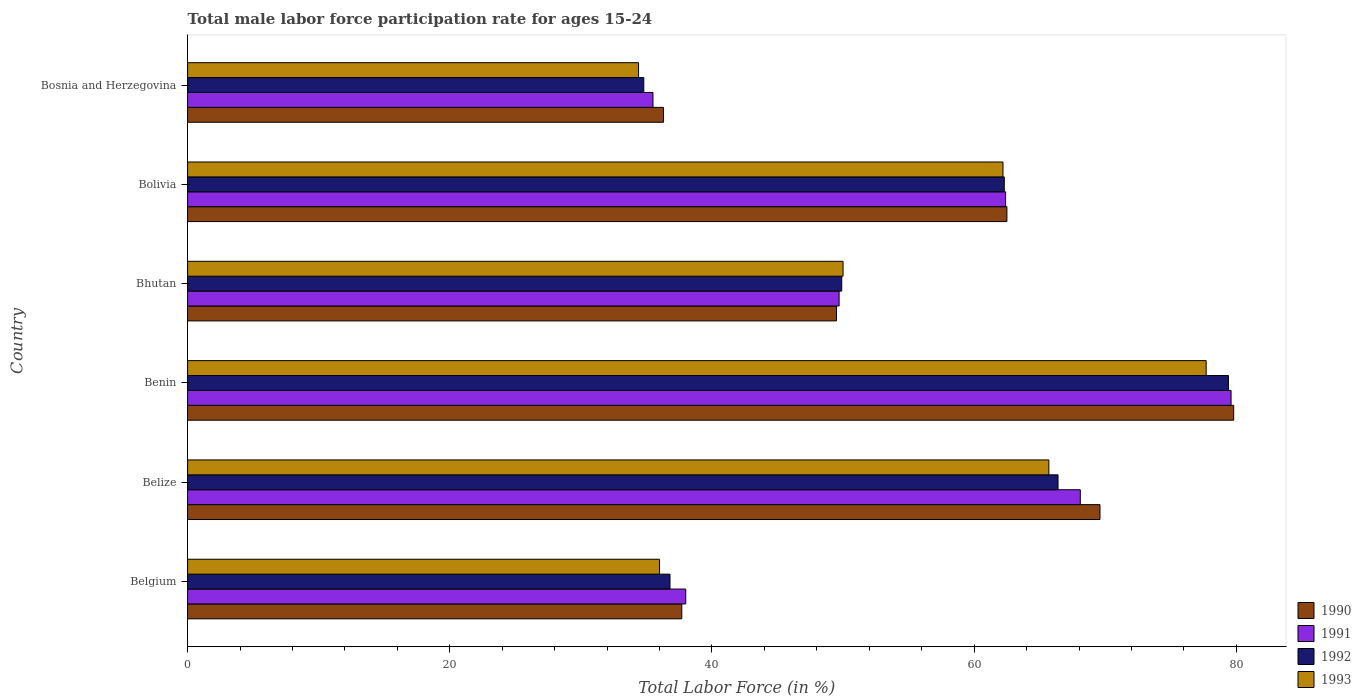How many groups of bars are there?
Offer a terse response. 6. Are the number of bars per tick equal to the number of legend labels?
Provide a succinct answer. Yes. How many bars are there on the 2nd tick from the top?
Ensure brevity in your answer.  4. What is the label of the 4th group of bars from the top?
Ensure brevity in your answer.  Benin. In how many cases, is the number of bars for a given country not equal to the number of legend labels?
Give a very brief answer. 0. What is the male labor force participation rate in 1991 in Bosnia and Herzegovina?
Your response must be concise. 35.5. Across all countries, what is the maximum male labor force participation rate in 1992?
Your response must be concise. 79.4. Across all countries, what is the minimum male labor force participation rate in 1991?
Offer a terse response. 35.5. In which country was the male labor force participation rate in 1990 maximum?
Offer a terse response. Benin. In which country was the male labor force participation rate in 1990 minimum?
Your answer should be very brief. Bosnia and Herzegovina. What is the total male labor force participation rate in 1991 in the graph?
Keep it short and to the point. 333.3. What is the difference between the male labor force participation rate in 1990 in Bhutan and that in Bolivia?
Keep it short and to the point. -13. What is the difference between the male labor force participation rate in 1992 in Bhutan and the male labor force participation rate in 1991 in Belize?
Provide a short and direct response. -18.2. What is the average male labor force participation rate in 1990 per country?
Offer a terse response. 55.9. What is the ratio of the male labor force participation rate in 1993 in Bolivia to that in Bosnia and Herzegovina?
Ensure brevity in your answer.  1.81. Is the male labor force participation rate in 1991 in Bolivia less than that in Bosnia and Herzegovina?
Your response must be concise. No. What is the difference between the highest and the lowest male labor force participation rate in 1993?
Offer a terse response. 43.3. In how many countries, is the male labor force participation rate in 1991 greater than the average male labor force participation rate in 1991 taken over all countries?
Your response must be concise. 3. Is it the case that in every country, the sum of the male labor force participation rate in 1991 and male labor force participation rate in 1993 is greater than the sum of male labor force participation rate in 1990 and male labor force participation rate in 1992?
Provide a short and direct response. No. How many bars are there?
Your response must be concise. 24. Does the graph contain any zero values?
Keep it short and to the point. No. What is the title of the graph?
Ensure brevity in your answer.  Total male labor force participation rate for ages 15-24. What is the label or title of the X-axis?
Your response must be concise. Total Labor Force (in %). What is the Total Labor Force (in %) in 1990 in Belgium?
Keep it short and to the point. 37.7. What is the Total Labor Force (in %) of 1991 in Belgium?
Your answer should be very brief. 38. What is the Total Labor Force (in %) of 1992 in Belgium?
Offer a terse response. 36.8. What is the Total Labor Force (in %) in 1990 in Belize?
Provide a short and direct response. 69.6. What is the Total Labor Force (in %) of 1991 in Belize?
Keep it short and to the point. 68.1. What is the Total Labor Force (in %) in 1992 in Belize?
Give a very brief answer. 66.4. What is the Total Labor Force (in %) of 1993 in Belize?
Your response must be concise. 65.7. What is the Total Labor Force (in %) in 1990 in Benin?
Offer a terse response. 79.8. What is the Total Labor Force (in %) of 1991 in Benin?
Give a very brief answer. 79.6. What is the Total Labor Force (in %) of 1992 in Benin?
Your answer should be very brief. 79.4. What is the Total Labor Force (in %) of 1993 in Benin?
Give a very brief answer. 77.7. What is the Total Labor Force (in %) of 1990 in Bhutan?
Make the answer very short. 49.5. What is the Total Labor Force (in %) of 1991 in Bhutan?
Your answer should be very brief. 49.7. What is the Total Labor Force (in %) in 1992 in Bhutan?
Make the answer very short. 49.9. What is the Total Labor Force (in %) in 1993 in Bhutan?
Your response must be concise. 50. What is the Total Labor Force (in %) in 1990 in Bolivia?
Offer a terse response. 62.5. What is the Total Labor Force (in %) of 1991 in Bolivia?
Offer a very short reply. 62.4. What is the Total Labor Force (in %) in 1992 in Bolivia?
Keep it short and to the point. 62.3. What is the Total Labor Force (in %) of 1993 in Bolivia?
Offer a very short reply. 62.2. What is the Total Labor Force (in %) in 1990 in Bosnia and Herzegovina?
Give a very brief answer. 36.3. What is the Total Labor Force (in %) in 1991 in Bosnia and Herzegovina?
Give a very brief answer. 35.5. What is the Total Labor Force (in %) of 1992 in Bosnia and Herzegovina?
Ensure brevity in your answer.  34.8. What is the Total Labor Force (in %) in 1993 in Bosnia and Herzegovina?
Your answer should be compact. 34.4. Across all countries, what is the maximum Total Labor Force (in %) of 1990?
Provide a succinct answer. 79.8. Across all countries, what is the maximum Total Labor Force (in %) of 1991?
Your answer should be compact. 79.6. Across all countries, what is the maximum Total Labor Force (in %) of 1992?
Keep it short and to the point. 79.4. Across all countries, what is the maximum Total Labor Force (in %) in 1993?
Make the answer very short. 77.7. Across all countries, what is the minimum Total Labor Force (in %) of 1990?
Your answer should be compact. 36.3. Across all countries, what is the minimum Total Labor Force (in %) of 1991?
Your answer should be compact. 35.5. Across all countries, what is the minimum Total Labor Force (in %) of 1992?
Provide a succinct answer. 34.8. Across all countries, what is the minimum Total Labor Force (in %) of 1993?
Give a very brief answer. 34.4. What is the total Total Labor Force (in %) of 1990 in the graph?
Offer a terse response. 335.4. What is the total Total Labor Force (in %) of 1991 in the graph?
Ensure brevity in your answer.  333.3. What is the total Total Labor Force (in %) in 1992 in the graph?
Give a very brief answer. 329.6. What is the total Total Labor Force (in %) of 1993 in the graph?
Offer a terse response. 326. What is the difference between the Total Labor Force (in %) in 1990 in Belgium and that in Belize?
Offer a very short reply. -31.9. What is the difference between the Total Labor Force (in %) in 1991 in Belgium and that in Belize?
Keep it short and to the point. -30.1. What is the difference between the Total Labor Force (in %) of 1992 in Belgium and that in Belize?
Ensure brevity in your answer.  -29.6. What is the difference between the Total Labor Force (in %) in 1993 in Belgium and that in Belize?
Offer a very short reply. -29.7. What is the difference between the Total Labor Force (in %) in 1990 in Belgium and that in Benin?
Keep it short and to the point. -42.1. What is the difference between the Total Labor Force (in %) of 1991 in Belgium and that in Benin?
Provide a short and direct response. -41.6. What is the difference between the Total Labor Force (in %) of 1992 in Belgium and that in Benin?
Offer a very short reply. -42.6. What is the difference between the Total Labor Force (in %) in 1993 in Belgium and that in Benin?
Offer a very short reply. -41.7. What is the difference between the Total Labor Force (in %) of 1991 in Belgium and that in Bhutan?
Your answer should be very brief. -11.7. What is the difference between the Total Labor Force (in %) in 1992 in Belgium and that in Bhutan?
Give a very brief answer. -13.1. What is the difference between the Total Labor Force (in %) of 1993 in Belgium and that in Bhutan?
Ensure brevity in your answer.  -14. What is the difference between the Total Labor Force (in %) in 1990 in Belgium and that in Bolivia?
Make the answer very short. -24.8. What is the difference between the Total Labor Force (in %) in 1991 in Belgium and that in Bolivia?
Offer a very short reply. -24.4. What is the difference between the Total Labor Force (in %) of 1992 in Belgium and that in Bolivia?
Your answer should be very brief. -25.5. What is the difference between the Total Labor Force (in %) in 1993 in Belgium and that in Bolivia?
Give a very brief answer. -26.2. What is the difference between the Total Labor Force (in %) in 1991 in Belgium and that in Bosnia and Herzegovina?
Provide a succinct answer. 2.5. What is the difference between the Total Labor Force (in %) in 1992 in Belgium and that in Bosnia and Herzegovina?
Offer a very short reply. 2. What is the difference between the Total Labor Force (in %) in 1991 in Belize and that in Benin?
Your answer should be very brief. -11.5. What is the difference between the Total Labor Force (in %) of 1993 in Belize and that in Benin?
Ensure brevity in your answer.  -12. What is the difference between the Total Labor Force (in %) of 1990 in Belize and that in Bhutan?
Your answer should be compact. 20.1. What is the difference between the Total Labor Force (in %) in 1990 in Belize and that in Bolivia?
Make the answer very short. 7.1. What is the difference between the Total Labor Force (in %) of 1992 in Belize and that in Bolivia?
Provide a succinct answer. 4.1. What is the difference between the Total Labor Force (in %) in 1990 in Belize and that in Bosnia and Herzegovina?
Make the answer very short. 33.3. What is the difference between the Total Labor Force (in %) in 1991 in Belize and that in Bosnia and Herzegovina?
Give a very brief answer. 32.6. What is the difference between the Total Labor Force (in %) of 1992 in Belize and that in Bosnia and Herzegovina?
Give a very brief answer. 31.6. What is the difference between the Total Labor Force (in %) in 1993 in Belize and that in Bosnia and Herzegovina?
Your response must be concise. 31.3. What is the difference between the Total Labor Force (in %) of 1990 in Benin and that in Bhutan?
Your response must be concise. 30.3. What is the difference between the Total Labor Force (in %) in 1991 in Benin and that in Bhutan?
Your response must be concise. 29.9. What is the difference between the Total Labor Force (in %) in 1992 in Benin and that in Bhutan?
Ensure brevity in your answer.  29.5. What is the difference between the Total Labor Force (in %) of 1993 in Benin and that in Bhutan?
Keep it short and to the point. 27.7. What is the difference between the Total Labor Force (in %) of 1991 in Benin and that in Bolivia?
Ensure brevity in your answer.  17.2. What is the difference between the Total Labor Force (in %) in 1993 in Benin and that in Bolivia?
Your answer should be very brief. 15.5. What is the difference between the Total Labor Force (in %) of 1990 in Benin and that in Bosnia and Herzegovina?
Offer a terse response. 43.5. What is the difference between the Total Labor Force (in %) in 1991 in Benin and that in Bosnia and Herzegovina?
Keep it short and to the point. 44.1. What is the difference between the Total Labor Force (in %) of 1992 in Benin and that in Bosnia and Herzegovina?
Keep it short and to the point. 44.6. What is the difference between the Total Labor Force (in %) in 1993 in Benin and that in Bosnia and Herzegovina?
Your answer should be very brief. 43.3. What is the difference between the Total Labor Force (in %) of 1990 in Bhutan and that in Bolivia?
Your response must be concise. -13. What is the difference between the Total Labor Force (in %) of 1992 in Bhutan and that in Bolivia?
Offer a very short reply. -12.4. What is the difference between the Total Labor Force (in %) of 1991 in Bhutan and that in Bosnia and Herzegovina?
Ensure brevity in your answer.  14.2. What is the difference between the Total Labor Force (in %) of 1992 in Bhutan and that in Bosnia and Herzegovina?
Provide a short and direct response. 15.1. What is the difference between the Total Labor Force (in %) of 1990 in Bolivia and that in Bosnia and Herzegovina?
Offer a very short reply. 26.2. What is the difference between the Total Labor Force (in %) of 1991 in Bolivia and that in Bosnia and Herzegovina?
Give a very brief answer. 26.9. What is the difference between the Total Labor Force (in %) in 1992 in Bolivia and that in Bosnia and Herzegovina?
Ensure brevity in your answer.  27.5. What is the difference between the Total Labor Force (in %) of 1993 in Bolivia and that in Bosnia and Herzegovina?
Keep it short and to the point. 27.8. What is the difference between the Total Labor Force (in %) in 1990 in Belgium and the Total Labor Force (in %) in 1991 in Belize?
Your answer should be compact. -30.4. What is the difference between the Total Labor Force (in %) of 1990 in Belgium and the Total Labor Force (in %) of 1992 in Belize?
Keep it short and to the point. -28.7. What is the difference between the Total Labor Force (in %) in 1991 in Belgium and the Total Labor Force (in %) in 1992 in Belize?
Your response must be concise. -28.4. What is the difference between the Total Labor Force (in %) in 1991 in Belgium and the Total Labor Force (in %) in 1993 in Belize?
Your response must be concise. -27.7. What is the difference between the Total Labor Force (in %) in 1992 in Belgium and the Total Labor Force (in %) in 1993 in Belize?
Ensure brevity in your answer.  -28.9. What is the difference between the Total Labor Force (in %) in 1990 in Belgium and the Total Labor Force (in %) in 1991 in Benin?
Your answer should be compact. -41.9. What is the difference between the Total Labor Force (in %) in 1990 in Belgium and the Total Labor Force (in %) in 1992 in Benin?
Offer a very short reply. -41.7. What is the difference between the Total Labor Force (in %) of 1990 in Belgium and the Total Labor Force (in %) of 1993 in Benin?
Provide a short and direct response. -40. What is the difference between the Total Labor Force (in %) of 1991 in Belgium and the Total Labor Force (in %) of 1992 in Benin?
Offer a terse response. -41.4. What is the difference between the Total Labor Force (in %) in 1991 in Belgium and the Total Labor Force (in %) in 1993 in Benin?
Keep it short and to the point. -39.7. What is the difference between the Total Labor Force (in %) of 1992 in Belgium and the Total Labor Force (in %) of 1993 in Benin?
Provide a short and direct response. -40.9. What is the difference between the Total Labor Force (in %) in 1990 in Belgium and the Total Labor Force (in %) in 1993 in Bhutan?
Your answer should be compact. -12.3. What is the difference between the Total Labor Force (in %) of 1991 in Belgium and the Total Labor Force (in %) of 1992 in Bhutan?
Your answer should be very brief. -11.9. What is the difference between the Total Labor Force (in %) in 1991 in Belgium and the Total Labor Force (in %) in 1993 in Bhutan?
Your answer should be very brief. -12. What is the difference between the Total Labor Force (in %) in 1990 in Belgium and the Total Labor Force (in %) in 1991 in Bolivia?
Offer a very short reply. -24.7. What is the difference between the Total Labor Force (in %) of 1990 in Belgium and the Total Labor Force (in %) of 1992 in Bolivia?
Give a very brief answer. -24.6. What is the difference between the Total Labor Force (in %) of 1990 in Belgium and the Total Labor Force (in %) of 1993 in Bolivia?
Keep it short and to the point. -24.5. What is the difference between the Total Labor Force (in %) in 1991 in Belgium and the Total Labor Force (in %) in 1992 in Bolivia?
Your answer should be very brief. -24.3. What is the difference between the Total Labor Force (in %) in 1991 in Belgium and the Total Labor Force (in %) in 1993 in Bolivia?
Offer a terse response. -24.2. What is the difference between the Total Labor Force (in %) of 1992 in Belgium and the Total Labor Force (in %) of 1993 in Bolivia?
Make the answer very short. -25.4. What is the difference between the Total Labor Force (in %) in 1990 in Belgium and the Total Labor Force (in %) in 1991 in Bosnia and Herzegovina?
Your answer should be very brief. 2.2. What is the difference between the Total Labor Force (in %) of 1990 in Belgium and the Total Labor Force (in %) of 1992 in Bosnia and Herzegovina?
Make the answer very short. 2.9. What is the difference between the Total Labor Force (in %) in 1990 in Belgium and the Total Labor Force (in %) in 1993 in Bosnia and Herzegovina?
Give a very brief answer. 3.3. What is the difference between the Total Labor Force (in %) of 1991 in Belgium and the Total Labor Force (in %) of 1992 in Bosnia and Herzegovina?
Your answer should be very brief. 3.2. What is the difference between the Total Labor Force (in %) of 1990 in Belize and the Total Labor Force (in %) of 1991 in Benin?
Keep it short and to the point. -10. What is the difference between the Total Labor Force (in %) in 1990 in Belize and the Total Labor Force (in %) in 1993 in Benin?
Offer a very short reply. -8.1. What is the difference between the Total Labor Force (in %) in 1990 in Belize and the Total Labor Force (in %) in 1993 in Bhutan?
Offer a terse response. 19.6. What is the difference between the Total Labor Force (in %) of 1991 in Belize and the Total Labor Force (in %) of 1992 in Bhutan?
Provide a short and direct response. 18.2. What is the difference between the Total Labor Force (in %) in 1991 in Belize and the Total Labor Force (in %) in 1993 in Bhutan?
Your answer should be compact. 18.1. What is the difference between the Total Labor Force (in %) of 1990 in Belize and the Total Labor Force (in %) of 1991 in Bolivia?
Your answer should be very brief. 7.2. What is the difference between the Total Labor Force (in %) of 1990 in Belize and the Total Labor Force (in %) of 1992 in Bolivia?
Offer a very short reply. 7.3. What is the difference between the Total Labor Force (in %) of 1991 in Belize and the Total Labor Force (in %) of 1993 in Bolivia?
Make the answer very short. 5.9. What is the difference between the Total Labor Force (in %) in 1992 in Belize and the Total Labor Force (in %) in 1993 in Bolivia?
Your answer should be very brief. 4.2. What is the difference between the Total Labor Force (in %) of 1990 in Belize and the Total Labor Force (in %) of 1991 in Bosnia and Herzegovina?
Your answer should be compact. 34.1. What is the difference between the Total Labor Force (in %) in 1990 in Belize and the Total Labor Force (in %) in 1992 in Bosnia and Herzegovina?
Your answer should be very brief. 34.8. What is the difference between the Total Labor Force (in %) in 1990 in Belize and the Total Labor Force (in %) in 1993 in Bosnia and Herzegovina?
Give a very brief answer. 35.2. What is the difference between the Total Labor Force (in %) in 1991 in Belize and the Total Labor Force (in %) in 1992 in Bosnia and Herzegovina?
Offer a very short reply. 33.3. What is the difference between the Total Labor Force (in %) of 1991 in Belize and the Total Labor Force (in %) of 1993 in Bosnia and Herzegovina?
Your answer should be very brief. 33.7. What is the difference between the Total Labor Force (in %) in 1992 in Belize and the Total Labor Force (in %) in 1993 in Bosnia and Herzegovina?
Make the answer very short. 32. What is the difference between the Total Labor Force (in %) in 1990 in Benin and the Total Labor Force (in %) in 1991 in Bhutan?
Your answer should be very brief. 30.1. What is the difference between the Total Labor Force (in %) in 1990 in Benin and the Total Labor Force (in %) in 1992 in Bhutan?
Offer a terse response. 29.9. What is the difference between the Total Labor Force (in %) of 1990 in Benin and the Total Labor Force (in %) of 1993 in Bhutan?
Your answer should be compact. 29.8. What is the difference between the Total Labor Force (in %) in 1991 in Benin and the Total Labor Force (in %) in 1992 in Bhutan?
Give a very brief answer. 29.7. What is the difference between the Total Labor Force (in %) in 1991 in Benin and the Total Labor Force (in %) in 1993 in Bhutan?
Offer a very short reply. 29.6. What is the difference between the Total Labor Force (in %) of 1992 in Benin and the Total Labor Force (in %) of 1993 in Bhutan?
Give a very brief answer. 29.4. What is the difference between the Total Labor Force (in %) of 1990 in Benin and the Total Labor Force (in %) of 1992 in Bolivia?
Your answer should be compact. 17.5. What is the difference between the Total Labor Force (in %) in 1991 in Benin and the Total Labor Force (in %) in 1992 in Bolivia?
Your response must be concise. 17.3. What is the difference between the Total Labor Force (in %) of 1991 in Benin and the Total Labor Force (in %) of 1993 in Bolivia?
Your answer should be very brief. 17.4. What is the difference between the Total Labor Force (in %) of 1992 in Benin and the Total Labor Force (in %) of 1993 in Bolivia?
Offer a very short reply. 17.2. What is the difference between the Total Labor Force (in %) of 1990 in Benin and the Total Labor Force (in %) of 1991 in Bosnia and Herzegovina?
Your response must be concise. 44.3. What is the difference between the Total Labor Force (in %) in 1990 in Benin and the Total Labor Force (in %) in 1992 in Bosnia and Herzegovina?
Provide a short and direct response. 45. What is the difference between the Total Labor Force (in %) of 1990 in Benin and the Total Labor Force (in %) of 1993 in Bosnia and Herzegovina?
Your answer should be compact. 45.4. What is the difference between the Total Labor Force (in %) of 1991 in Benin and the Total Labor Force (in %) of 1992 in Bosnia and Herzegovina?
Provide a succinct answer. 44.8. What is the difference between the Total Labor Force (in %) of 1991 in Benin and the Total Labor Force (in %) of 1993 in Bosnia and Herzegovina?
Offer a terse response. 45.2. What is the difference between the Total Labor Force (in %) in 1990 in Bhutan and the Total Labor Force (in %) in 1991 in Bolivia?
Make the answer very short. -12.9. What is the difference between the Total Labor Force (in %) of 1991 in Bhutan and the Total Labor Force (in %) of 1993 in Bolivia?
Keep it short and to the point. -12.5. What is the difference between the Total Labor Force (in %) in 1992 in Bhutan and the Total Labor Force (in %) in 1993 in Bolivia?
Make the answer very short. -12.3. What is the difference between the Total Labor Force (in %) of 1990 in Bhutan and the Total Labor Force (in %) of 1993 in Bosnia and Herzegovina?
Provide a short and direct response. 15.1. What is the difference between the Total Labor Force (in %) in 1992 in Bhutan and the Total Labor Force (in %) in 1993 in Bosnia and Herzegovina?
Your response must be concise. 15.5. What is the difference between the Total Labor Force (in %) in 1990 in Bolivia and the Total Labor Force (in %) in 1991 in Bosnia and Herzegovina?
Give a very brief answer. 27. What is the difference between the Total Labor Force (in %) in 1990 in Bolivia and the Total Labor Force (in %) in 1992 in Bosnia and Herzegovina?
Give a very brief answer. 27.7. What is the difference between the Total Labor Force (in %) in 1990 in Bolivia and the Total Labor Force (in %) in 1993 in Bosnia and Herzegovina?
Keep it short and to the point. 28.1. What is the difference between the Total Labor Force (in %) of 1991 in Bolivia and the Total Labor Force (in %) of 1992 in Bosnia and Herzegovina?
Keep it short and to the point. 27.6. What is the difference between the Total Labor Force (in %) in 1992 in Bolivia and the Total Labor Force (in %) in 1993 in Bosnia and Herzegovina?
Your response must be concise. 27.9. What is the average Total Labor Force (in %) of 1990 per country?
Offer a terse response. 55.9. What is the average Total Labor Force (in %) of 1991 per country?
Your answer should be very brief. 55.55. What is the average Total Labor Force (in %) in 1992 per country?
Offer a terse response. 54.93. What is the average Total Labor Force (in %) of 1993 per country?
Offer a terse response. 54.33. What is the difference between the Total Labor Force (in %) of 1990 and Total Labor Force (in %) of 1992 in Belgium?
Provide a short and direct response. 0.9. What is the difference between the Total Labor Force (in %) of 1990 and Total Labor Force (in %) of 1993 in Belgium?
Give a very brief answer. 1.7. What is the difference between the Total Labor Force (in %) of 1990 and Total Labor Force (in %) of 1991 in Belize?
Ensure brevity in your answer.  1.5. What is the difference between the Total Labor Force (in %) of 1990 and Total Labor Force (in %) of 1992 in Belize?
Your response must be concise. 3.2. What is the difference between the Total Labor Force (in %) of 1991 and Total Labor Force (in %) of 1992 in Belize?
Offer a terse response. 1.7. What is the difference between the Total Labor Force (in %) of 1992 and Total Labor Force (in %) of 1993 in Belize?
Your answer should be compact. 0.7. What is the difference between the Total Labor Force (in %) in 1991 and Total Labor Force (in %) in 1992 in Benin?
Offer a terse response. 0.2. What is the difference between the Total Labor Force (in %) in 1991 and Total Labor Force (in %) in 1993 in Benin?
Provide a short and direct response. 1.9. What is the difference between the Total Labor Force (in %) of 1990 and Total Labor Force (in %) of 1991 in Bhutan?
Provide a succinct answer. -0.2. What is the difference between the Total Labor Force (in %) in 1991 and Total Labor Force (in %) in 1992 in Bhutan?
Give a very brief answer. -0.2. What is the difference between the Total Labor Force (in %) in 1991 and Total Labor Force (in %) in 1993 in Bhutan?
Your answer should be compact. -0.3. What is the difference between the Total Labor Force (in %) in 1992 and Total Labor Force (in %) in 1993 in Bhutan?
Provide a succinct answer. -0.1. What is the difference between the Total Labor Force (in %) of 1990 and Total Labor Force (in %) of 1991 in Bolivia?
Your answer should be very brief. 0.1. What is the difference between the Total Labor Force (in %) in 1990 and Total Labor Force (in %) in 1993 in Bolivia?
Your response must be concise. 0.3. What is the difference between the Total Labor Force (in %) in 1991 and Total Labor Force (in %) in 1992 in Bolivia?
Give a very brief answer. 0.1. What is the difference between the Total Labor Force (in %) in 1990 and Total Labor Force (in %) in 1992 in Bosnia and Herzegovina?
Your answer should be compact. 1.5. What is the difference between the Total Labor Force (in %) of 1990 and Total Labor Force (in %) of 1993 in Bosnia and Herzegovina?
Your answer should be very brief. 1.9. What is the difference between the Total Labor Force (in %) in 1991 and Total Labor Force (in %) in 1992 in Bosnia and Herzegovina?
Your response must be concise. 0.7. What is the difference between the Total Labor Force (in %) in 1991 and Total Labor Force (in %) in 1993 in Bosnia and Herzegovina?
Make the answer very short. 1.1. What is the difference between the Total Labor Force (in %) in 1992 and Total Labor Force (in %) in 1993 in Bosnia and Herzegovina?
Your response must be concise. 0.4. What is the ratio of the Total Labor Force (in %) in 1990 in Belgium to that in Belize?
Make the answer very short. 0.54. What is the ratio of the Total Labor Force (in %) of 1991 in Belgium to that in Belize?
Keep it short and to the point. 0.56. What is the ratio of the Total Labor Force (in %) in 1992 in Belgium to that in Belize?
Your response must be concise. 0.55. What is the ratio of the Total Labor Force (in %) of 1993 in Belgium to that in Belize?
Offer a very short reply. 0.55. What is the ratio of the Total Labor Force (in %) in 1990 in Belgium to that in Benin?
Keep it short and to the point. 0.47. What is the ratio of the Total Labor Force (in %) of 1991 in Belgium to that in Benin?
Your answer should be compact. 0.48. What is the ratio of the Total Labor Force (in %) of 1992 in Belgium to that in Benin?
Ensure brevity in your answer.  0.46. What is the ratio of the Total Labor Force (in %) of 1993 in Belgium to that in Benin?
Offer a very short reply. 0.46. What is the ratio of the Total Labor Force (in %) in 1990 in Belgium to that in Bhutan?
Ensure brevity in your answer.  0.76. What is the ratio of the Total Labor Force (in %) of 1991 in Belgium to that in Bhutan?
Provide a succinct answer. 0.76. What is the ratio of the Total Labor Force (in %) in 1992 in Belgium to that in Bhutan?
Your answer should be compact. 0.74. What is the ratio of the Total Labor Force (in %) in 1993 in Belgium to that in Bhutan?
Give a very brief answer. 0.72. What is the ratio of the Total Labor Force (in %) in 1990 in Belgium to that in Bolivia?
Keep it short and to the point. 0.6. What is the ratio of the Total Labor Force (in %) of 1991 in Belgium to that in Bolivia?
Your answer should be compact. 0.61. What is the ratio of the Total Labor Force (in %) of 1992 in Belgium to that in Bolivia?
Give a very brief answer. 0.59. What is the ratio of the Total Labor Force (in %) in 1993 in Belgium to that in Bolivia?
Offer a terse response. 0.58. What is the ratio of the Total Labor Force (in %) in 1990 in Belgium to that in Bosnia and Herzegovina?
Your response must be concise. 1.04. What is the ratio of the Total Labor Force (in %) of 1991 in Belgium to that in Bosnia and Herzegovina?
Ensure brevity in your answer.  1.07. What is the ratio of the Total Labor Force (in %) of 1992 in Belgium to that in Bosnia and Herzegovina?
Offer a very short reply. 1.06. What is the ratio of the Total Labor Force (in %) in 1993 in Belgium to that in Bosnia and Herzegovina?
Your response must be concise. 1.05. What is the ratio of the Total Labor Force (in %) in 1990 in Belize to that in Benin?
Make the answer very short. 0.87. What is the ratio of the Total Labor Force (in %) of 1991 in Belize to that in Benin?
Ensure brevity in your answer.  0.86. What is the ratio of the Total Labor Force (in %) in 1992 in Belize to that in Benin?
Give a very brief answer. 0.84. What is the ratio of the Total Labor Force (in %) in 1993 in Belize to that in Benin?
Your answer should be very brief. 0.85. What is the ratio of the Total Labor Force (in %) in 1990 in Belize to that in Bhutan?
Your answer should be compact. 1.41. What is the ratio of the Total Labor Force (in %) of 1991 in Belize to that in Bhutan?
Your answer should be very brief. 1.37. What is the ratio of the Total Labor Force (in %) of 1992 in Belize to that in Bhutan?
Provide a succinct answer. 1.33. What is the ratio of the Total Labor Force (in %) in 1993 in Belize to that in Bhutan?
Your answer should be compact. 1.31. What is the ratio of the Total Labor Force (in %) of 1990 in Belize to that in Bolivia?
Ensure brevity in your answer.  1.11. What is the ratio of the Total Labor Force (in %) of 1991 in Belize to that in Bolivia?
Offer a terse response. 1.09. What is the ratio of the Total Labor Force (in %) in 1992 in Belize to that in Bolivia?
Give a very brief answer. 1.07. What is the ratio of the Total Labor Force (in %) in 1993 in Belize to that in Bolivia?
Offer a very short reply. 1.06. What is the ratio of the Total Labor Force (in %) in 1990 in Belize to that in Bosnia and Herzegovina?
Your answer should be very brief. 1.92. What is the ratio of the Total Labor Force (in %) in 1991 in Belize to that in Bosnia and Herzegovina?
Your response must be concise. 1.92. What is the ratio of the Total Labor Force (in %) in 1992 in Belize to that in Bosnia and Herzegovina?
Your answer should be compact. 1.91. What is the ratio of the Total Labor Force (in %) of 1993 in Belize to that in Bosnia and Herzegovina?
Your answer should be very brief. 1.91. What is the ratio of the Total Labor Force (in %) of 1990 in Benin to that in Bhutan?
Provide a short and direct response. 1.61. What is the ratio of the Total Labor Force (in %) in 1991 in Benin to that in Bhutan?
Give a very brief answer. 1.6. What is the ratio of the Total Labor Force (in %) in 1992 in Benin to that in Bhutan?
Keep it short and to the point. 1.59. What is the ratio of the Total Labor Force (in %) of 1993 in Benin to that in Bhutan?
Your response must be concise. 1.55. What is the ratio of the Total Labor Force (in %) of 1990 in Benin to that in Bolivia?
Make the answer very short. 1.28. What is the ratio of the Total Labor Force (in %) in 1991 in Benin to that in Bolivia?
Ensure brevity in your answer.  1.28. What is the ratio of the Total Labor Force (in %) of 1992 in Benin to that in Bolivia?
Offer a very short reply. 1.27. What is the ratio of the Total Labor Force (in %) of 1993 in Benin to that in Bolivia?
Your response must be concise. 1.25. What is the ratio of the Total Labor Force (in %) of 1990 in Benin to that in Bosnia and Herzegovina?
Offer a very short reply. 2.2. What is the ratio of the Total Labor Force (in %) in 1991 in Benin to that in Bosnia and Herzegovina?
Make the answer very short. 2.24. What is the ratio of the Total Labor Force (in %) of 1992 in Benin to that in Bosnia and Herzegovina?
Provide a short and direct response. 2.28. What is the ratio of the Total Labor Force (in %) of 1993 in Benin to that in Bosnia and Herzegovina?
Offer a terse response. 2.26. What is the ratio of the Total Labor Force (in %) in 1990 in Bhutan to that in Bolivia?
Your response must be concise. 0.79. What is the ratio of the Total Labor Force (in %) of 1991 in Bhutan to that in Bolivia?
Your answer should be very brief. 0.8. What is the ratio of the Total Labor Force (in %) in 1992 in Bhutan to that in Bolivia?
Provide a succinct answer. 0.8. What is the ratio of the Total Labor Force (in %) in 1993 in Bhutan to that in Bolivia?
Offer a terse response. 0.8. What is the ratio of the Total Labor Force (in %) of 1990 in Bhutan to that in Bosnia and Herzegovina?
Your response must be concise. 1.36. What is the ratio of the Total Labor Force (in %) of 1991 in Bhutan to that in Bosnia and Herzegovina?
Ensure brevity in your answer.  1.4. What is the ratio of the Total Labor Force (in %) of 1992 in Bhutan to that in Bosnia and Herzegovina?
Your answer should be compact. 1.43. What is the ratio of the Total Labor Force (in %) in 1993 in Bhutan to that in Bosnia and Herzegovina?
Your response must be concise. 1.45. What is the ratio of the Total Labor Force (in %) of 1990 in Bolivia to that in Bosnia and Herzegovina?
Your answer should be compact. 1.72. What is the ratio of the Total Labor Force (in %) in 1991 in Bolivia to that in Bosnia and Herzegovina?
Keep it short and to the point. 1.76. What is the ratio of the Total Labor Force (in %) in 1992 in Bolivia to that in Bosnia and Herzegovina?
Provide a short and direct response. 1.79. What is the ratio of the Total Labor Force (in %) of 1993 in Bolivia to that in Bosnia and Herzegovina?
Offer a terse response. 1.81. What is the difference between the highest and the second highest Total Labor Force (in %) in 1990?
Your answer should be very brief. 10.2. What is the difference between the highest and the second highest Total Labor Force (in %) of 1991?
Give a very brief answer. 11.5. What is the difference between the highest and the second highest Total Labor Force (in %) in 1992?
Provide a succinct answer. 13. What is the difference between the highest and the lowest Total Labor Force (in %) of 1990?
Ensure brevity in your answer.  43.5. What is the difference between the highest and the lowest Total Labor Force (in %) of 1991?
Provide a succinct answer. 44.1. What is the difference between the highest and the lowest Total Labor Force (in %) in 1992?
Give a very brief answer. 44.6. What is the difference between the highest and the lowest Total Labor Force (in %) in 1993?
Ensure brevity in your answer.  43.3. 